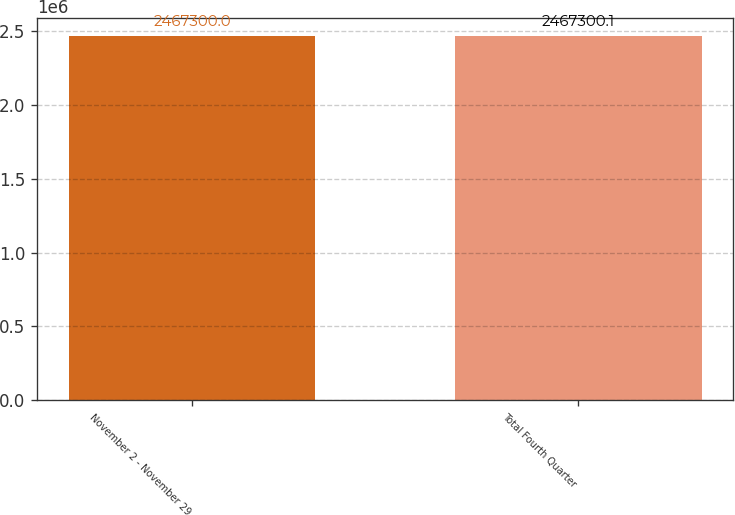Convert chart to OTSL. <chart><loc_0><loc_0><loc_500><loc_500><bar_chart><fcel>November 2 - November 29<fcel>Total Fourth Quarter<nl><fcel>2.4673e+06<fcel>2.4673e+06<nl></chart> 